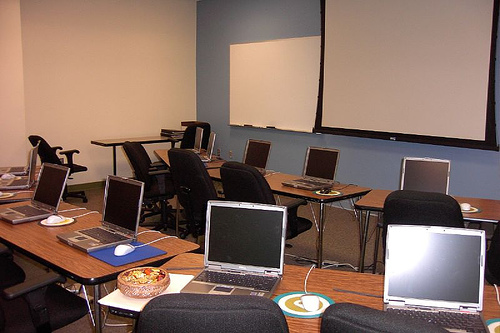What kind of meeting might take place in this room? Based on the set up of the room with multiple laptops, a projector screen, and a conference table, it seems like a corporate meeting or a professional training session could take place here. 